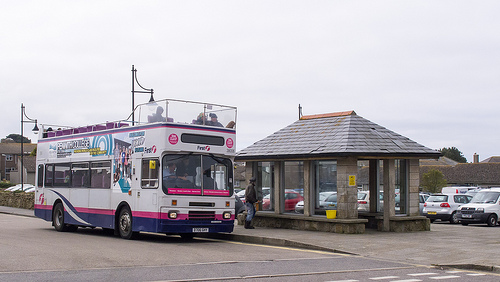On which side is the white vehicle? The white vehicle is on the left side. 